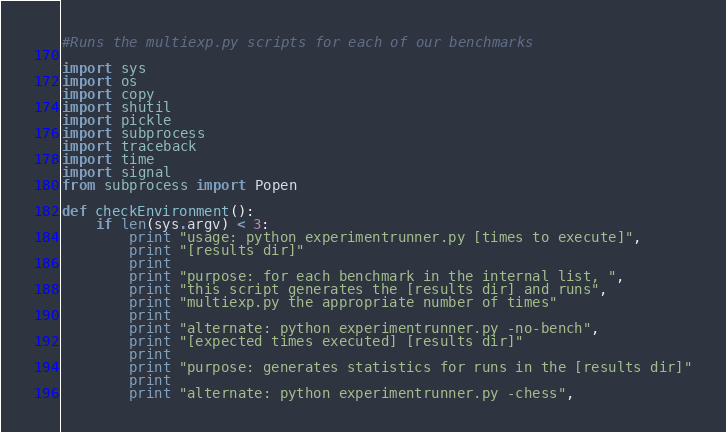Convert code to text. <code><loc_0><loc_0><loc_500><loc_500><_Python_>#Runs the multiexp.py scripts for each of our benchmarks

import sys
import os
import copy
import shutil
import pickle
import subprocess
import traceback
import time
import signal
from subprocess import Popen

def checkEnvironment():
    if len(sys.argv) < 3:
        print "usage: python experimentrunner.py [times to execute]",
        print "[results dir]"
        print
        print "purpose: for each benchmark in the internal list, ",
        print "this script generates the [results dir] and runs",
        print "multiexp.py the appropriate number of times"
        print
        print "alternate: python experimentrunner.py -no-bench",
        print "[expected times executed] [results dir]"
        print
        print "purpose: generates statistics for runs in the [results dir]"
        print
        print "alternate: python experimentrunner.py -chess",</code> 